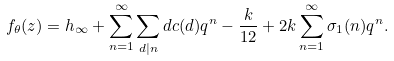Convert formula to latex. <formula><loc_0><loc_0><loc_500><loc_500>f _ { \theta } ( z ) = h _ { \infty } + \sum _ { n = 1 } ^ { \infty } \sum _ { d | n } d c ( d ) q ^ { n } - \frac { k } { 1 2 } + 2 k \sum _ { n = 1 } ^ { \infty } \sigma _ { 1 } ( n ) q ^ { n } .</formula> 